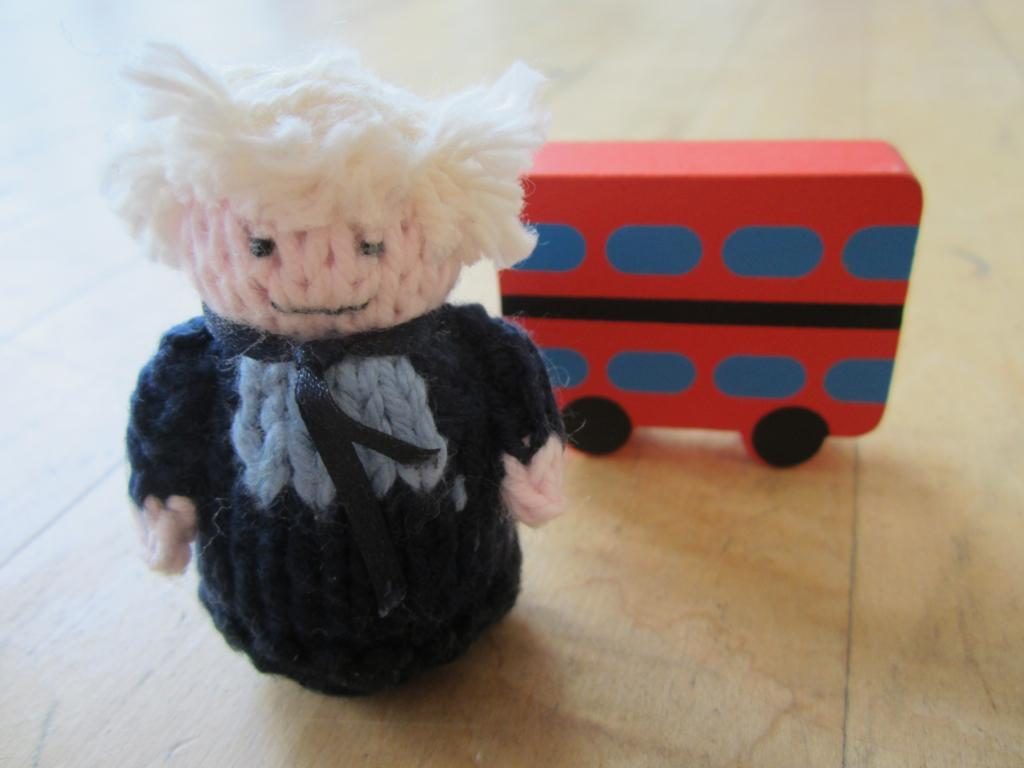What type of toys are featured in the image? There are handmade toys in the image. Can you describe the appearance of one of the toys? One toy looks like a person. What is the appearance of another toy in the image? Another toy looks like a bus. What degree of difficulty does the ghost in the image present to the person toy? There is no ghost present in the image, so this question cannot be answered. 